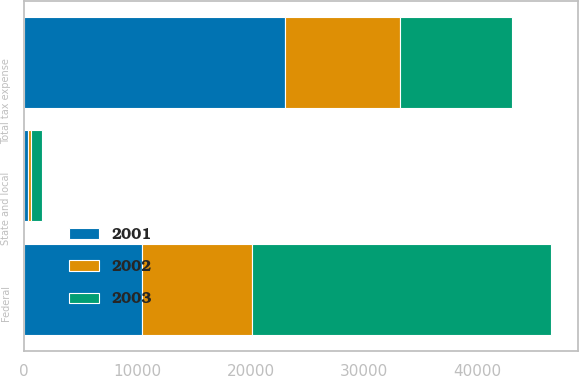Convert chart. <chart><loc_0><loc_0><loc_500><loc_500><stacked_bar_chart><ecel><fcel>Federal<fcel>State and local<fcel>Total tax expense<nl><fcel>2003<fcel>26439<fcel>1028<fcel>9899<nl><fcel>2001<fcel>10413<fcel>343<fcel>23031<nl><fcel>2002<fcel>9661<fcel>225<fcel>10137<nl></chart> 